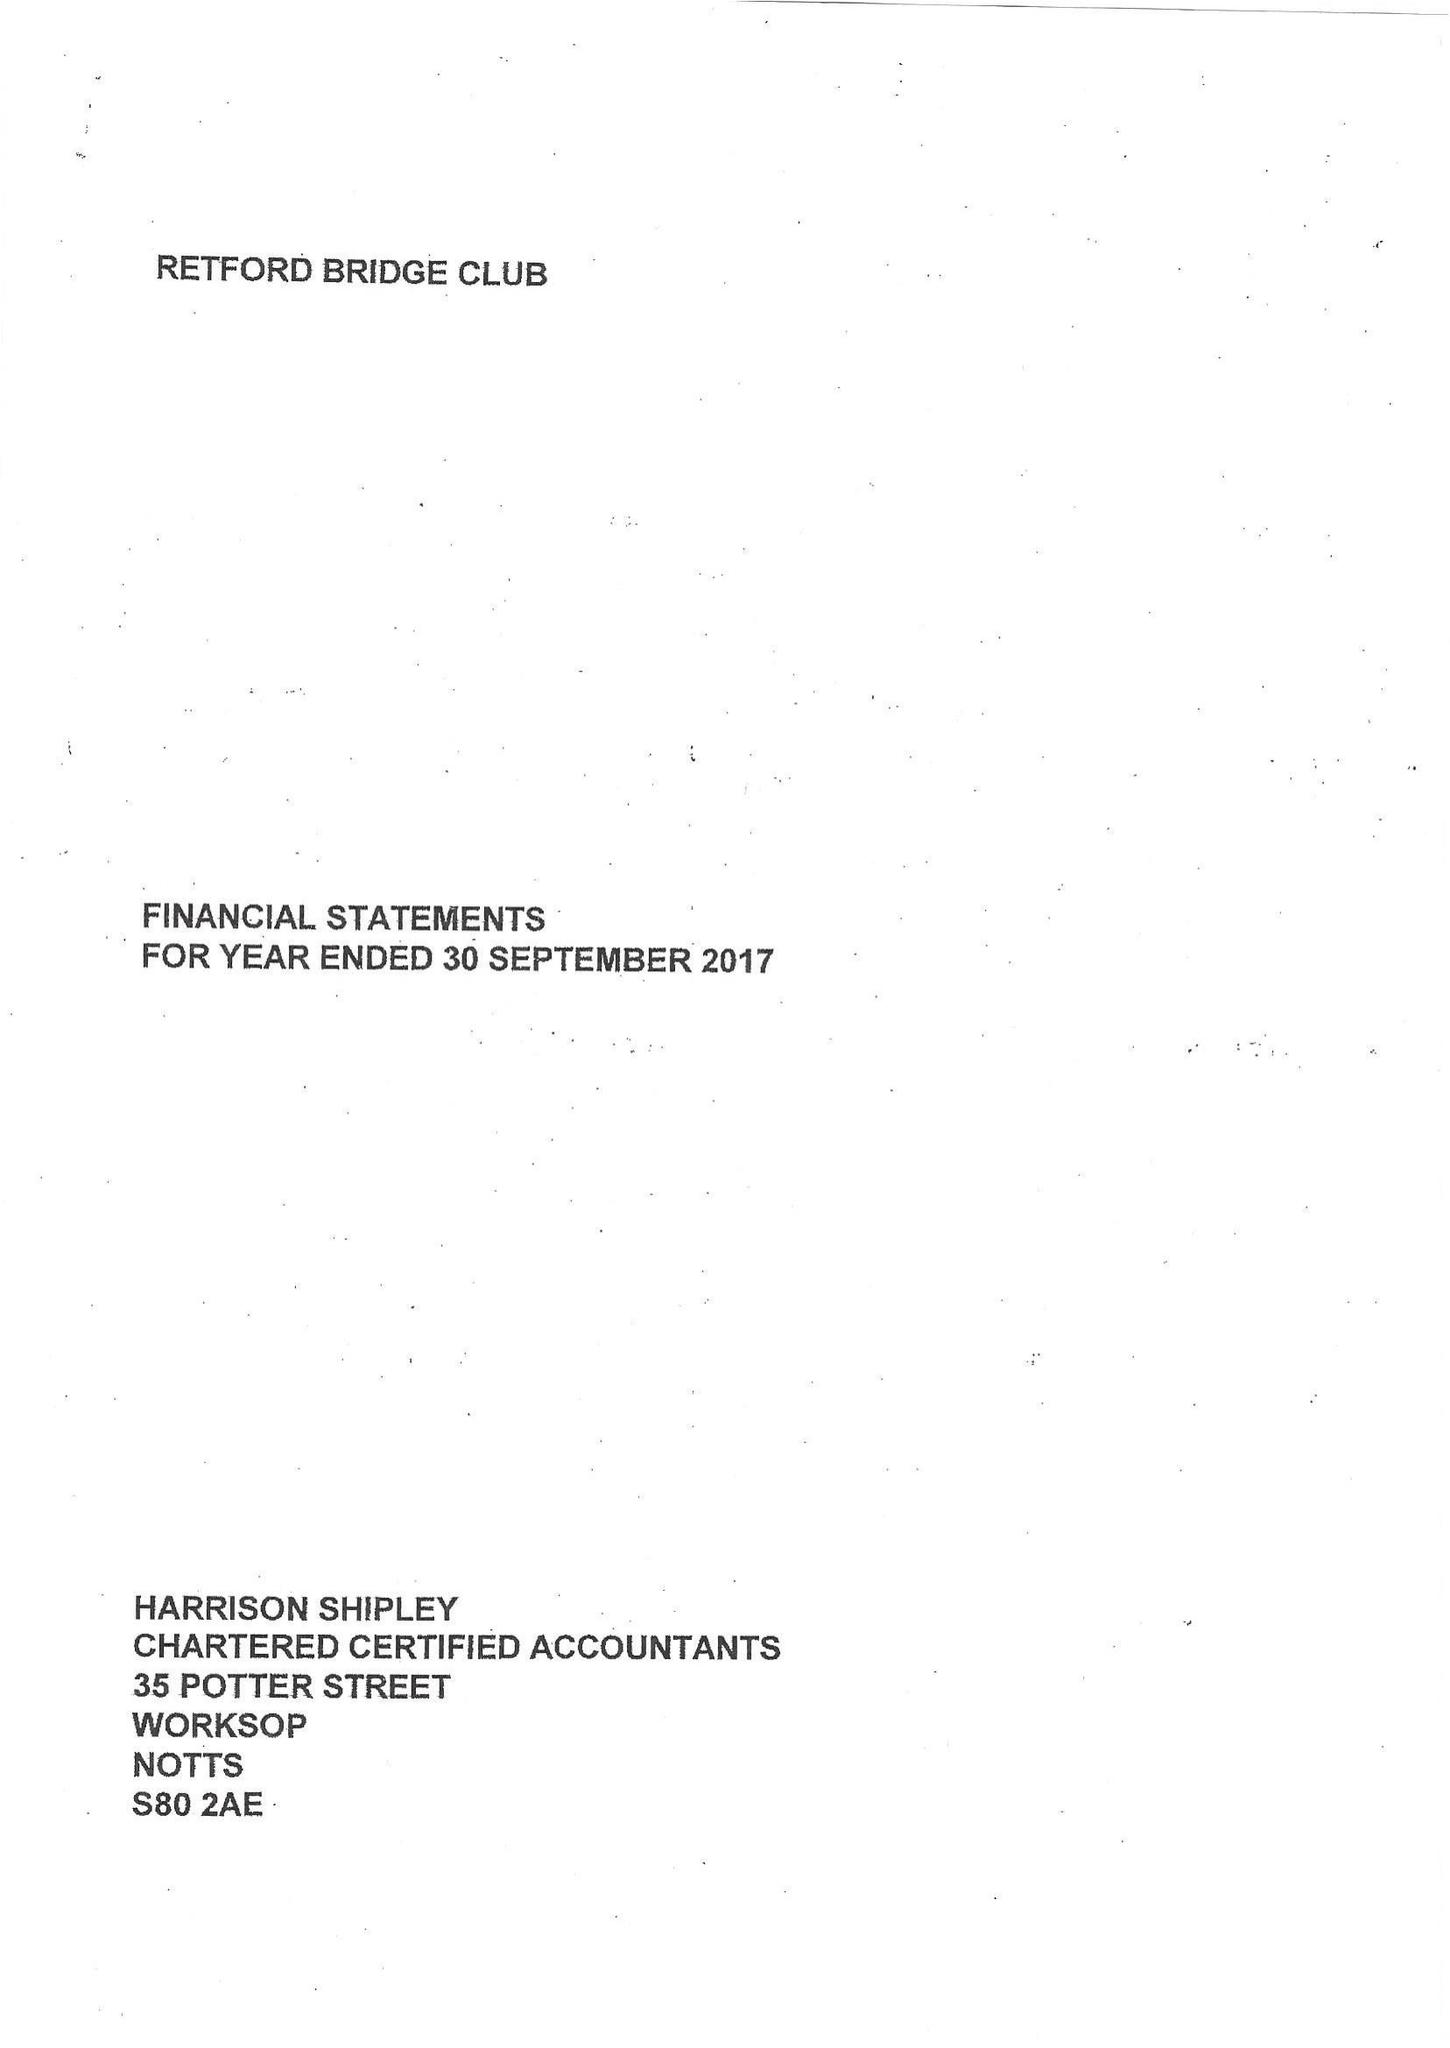What is the value for the address__street_line?
Answer the question using a single word or phrase. 13 THE MALTINGS 